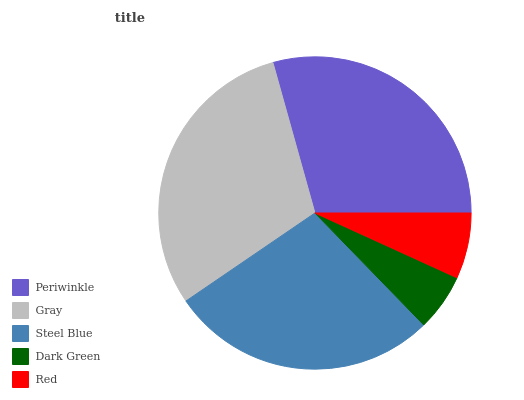Is Dark Green the minimum?
Answer yes or no. Yes. Is Gray the maximum?
Answer yes or no. Yes. Is Steel Blue the minimum?
Answer yes or no. No. Is Steel Blue the maximum?
Answer yes or no. No. Is Gray greater than Steel Blue?
Answer yes or no. Yes. Is Steel Blue less than Gray?
Answer yes or no. Yes. Is Steel Blue greater than Gray?
Answer yes or no. No. Is Gray less than Steel Blue?
Answer yes or no. No. Is Steel Blue the high median?
Answer yes or no. Yes. Is Steel Blue the low median?
Answer yes or no. Yes. Is Red the high median?
Answer yes or no. No. Is Periwinkle the low median?
Answer yes or no. No. 